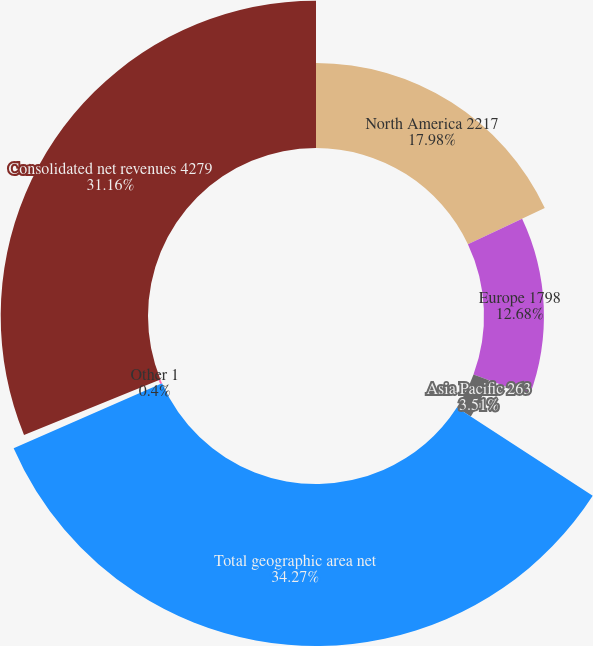Convert chart to OTSL. <chart><loc_0><loc_0><loc_500><loc_500><pie_chart><fcel>North America 2217<fcel>Europe 1798<fcel>Asia Pacific 263<fcel>Total geographic area net<fcel>Other 1<fcel>Consolidated net revenues 4279<nl><fcel>17.98%<fcel>12.68%<fcel>3.51%<fcel>34.27%<fcel>0.4%<fcel>31.16%<nl></chart> 